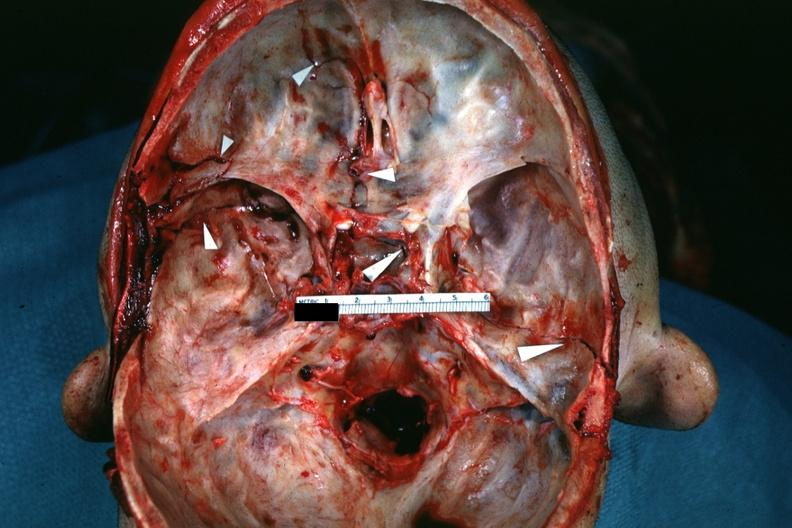what is present?
Answer the question using a single word or phrase. Bone 